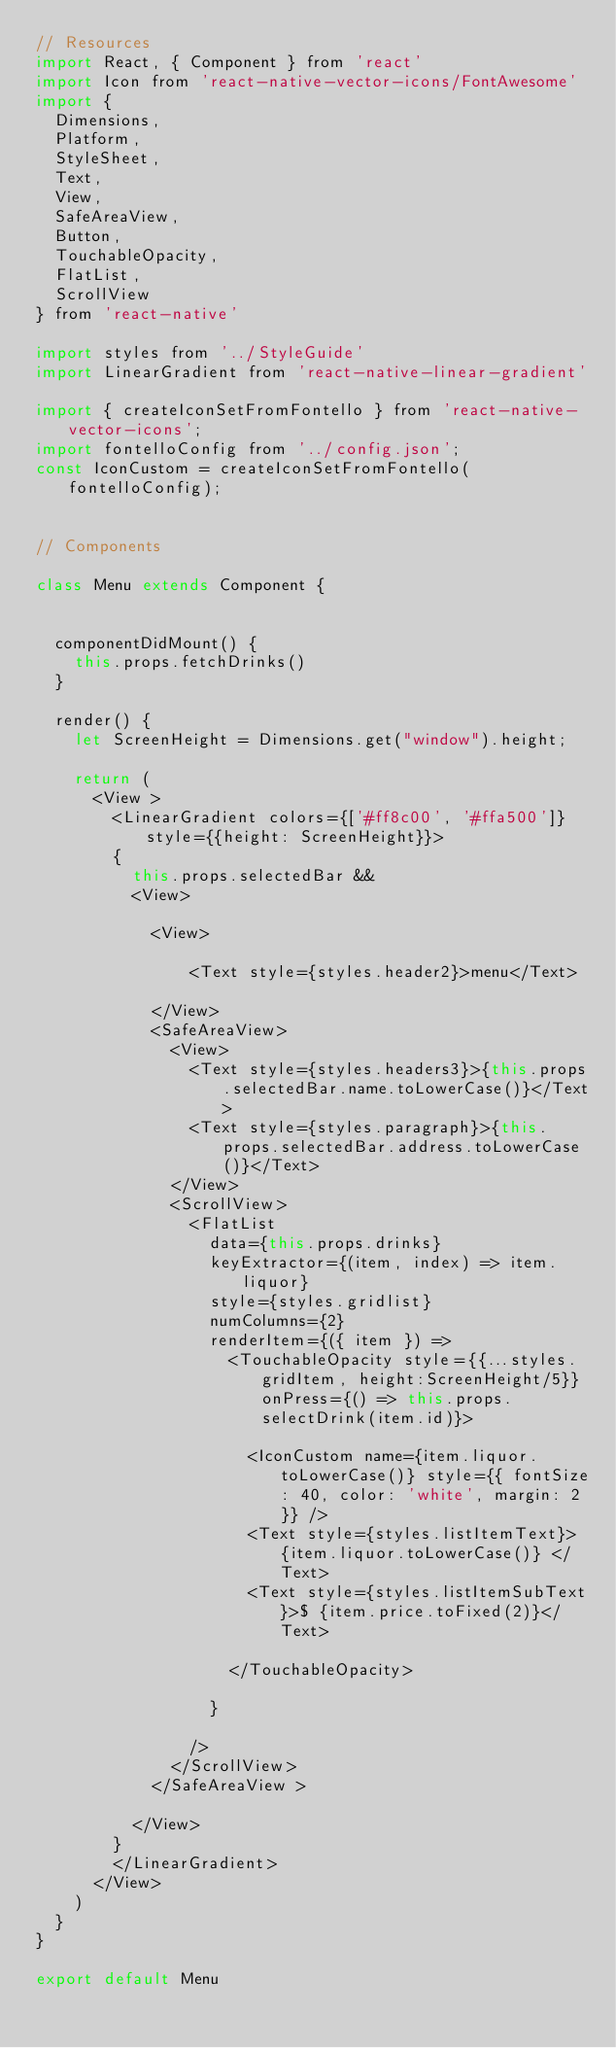<code> <loc_0><loc_0><loc_500><loc_500><_JavaScript_>// Resources
import React, { Component } from 'react'
import Icon from 'react-native-vector-icons/FontAwesome'
import {
  Dimensions,
  Platform,
  StyleSheet,
  Text,
  View,
  SafeAreaView,
  Button,
  TouchableOpacity,
  FlatList,
  ScrollView
} from 'react-native'

import styles from '../StyleGuide'
import LinearGradient from 'react-native-linear-gradient'

import { createIconSetFromFontello } from 'react-native-vector-icons';
import fontelloConfig from '../config.json';
const IconCustom = createIconSetFromFontello(fontelloConfig);


// Components

class Menu extends Component {


  componentDidMount() {
    this.props.fetchDrinks()
  }

  render() {
    let ScreenHeight = Dimensions.get("window").height;

    return (
      <View >
        <LinearGradient colors={['#ff8c00', '#ffa500']} style={{height: ScreenHeight}}>
        {
          this.props.selectedBar &&
          <View>
            
            <View>
              
                <Text style={styles.header2}>menu</Text>
              
            </View>
            <SafeAreaView>
              <View>
                <Text style={styles.headers3}>{this.props.selectedBar.name.toLowerCase()}</Text>
                <Text style={styles.paragraph}>{this.props.selectedBar.address.toLowerCase()}</Text>
              </View>
              <ScrollView>
                <FlatList
                  data={this.props.drinks}
                  keyExtractor={(item, index) => item.liquor}
                  style={styles.gridlist}
                  numColumns={2}
                  renderItem={({ item }) =>
                    <TouchableOpacity style={{...styles.gridItem, height:ScreenHeight/5}} onPress={() => this.props.selectDrink(item.id)}>

                      <IconCustom name={item.liquor.toLowerCase()} style={{ fontSize: 40, color: 'white', margin: 2 }} />
                      <Text style={styles.listItemText}> {item.liquor.toLowerCase()} </Text>
                      <Text style={styles.listItemSubText}>$ {item.price.toFixed(2)}</Text>

                    </TouchableOpacity>

                  }

                />
              </ScrollView>
            </SafeAreaView >
            
          </View>
        }
        </LinearGradient>
      </View>
    )
  }
}

export default Menu
</code> 